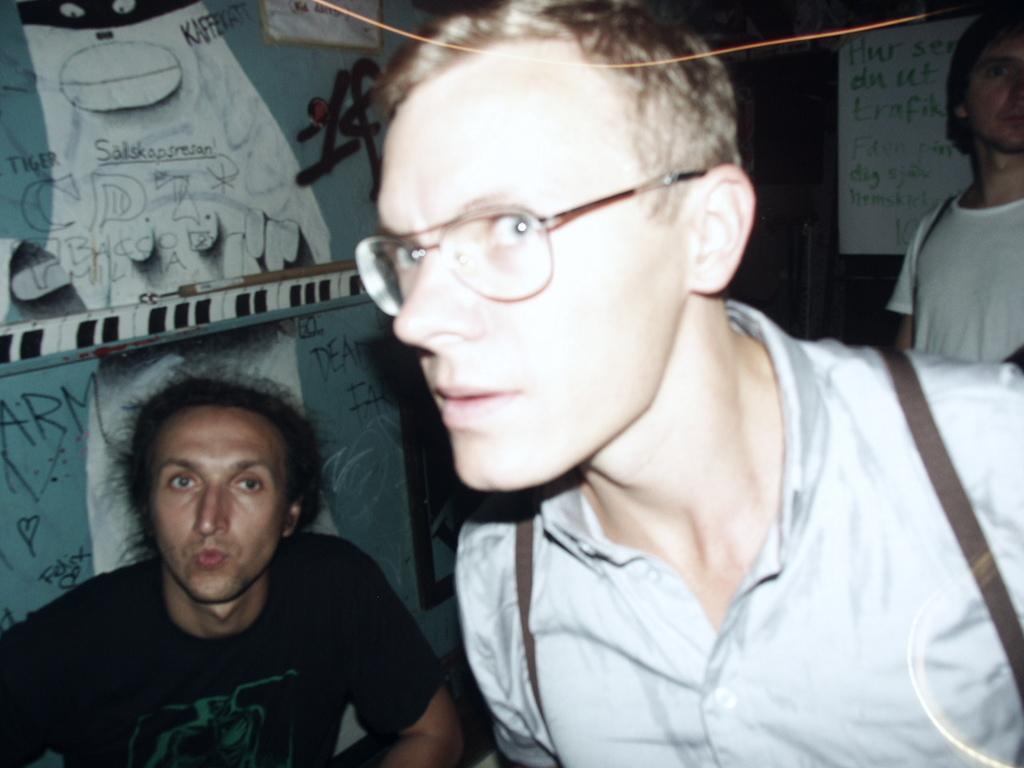Could you give a brief overview of what you see in this image? In this image we can see people. In the background there are boards placed on the wall. 